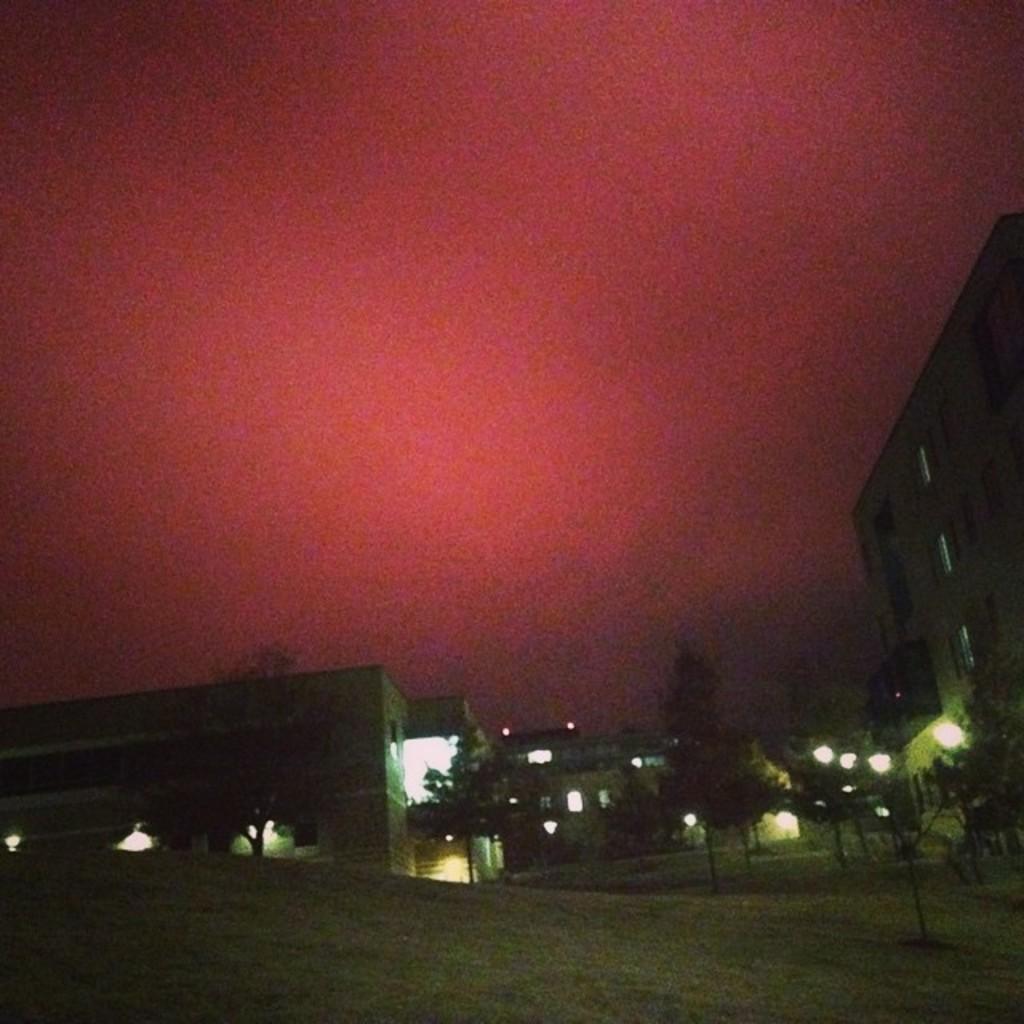Can you describe this image briefly? In this picture we can see few buildings, poles, lights and trees. 